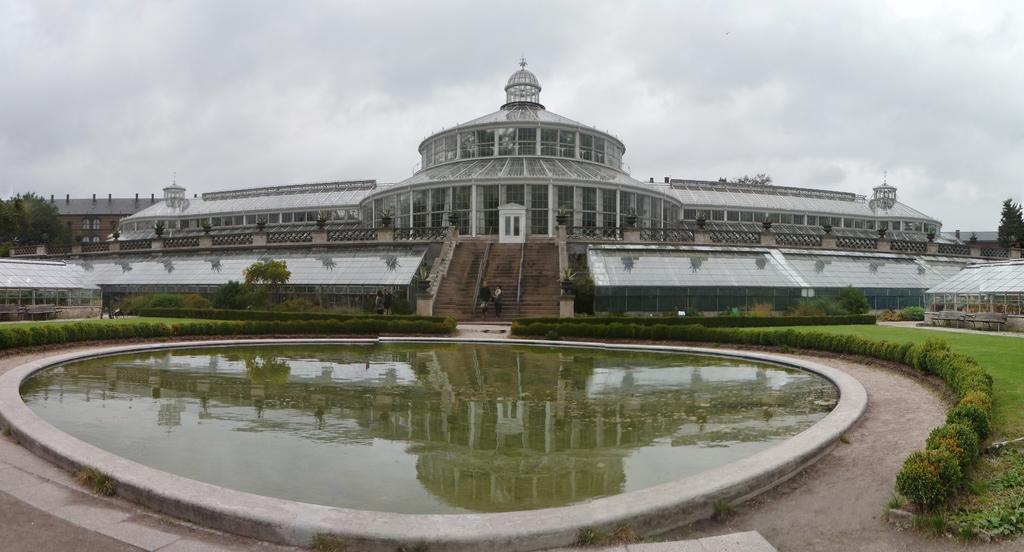Could you give a brief overview of what you see in this image? In this image I see few buildings and I see few people and I see a pond over here and I can also see the bushes, grass, trees and in the background I see the sky which is cloudy and I see the path over here. 